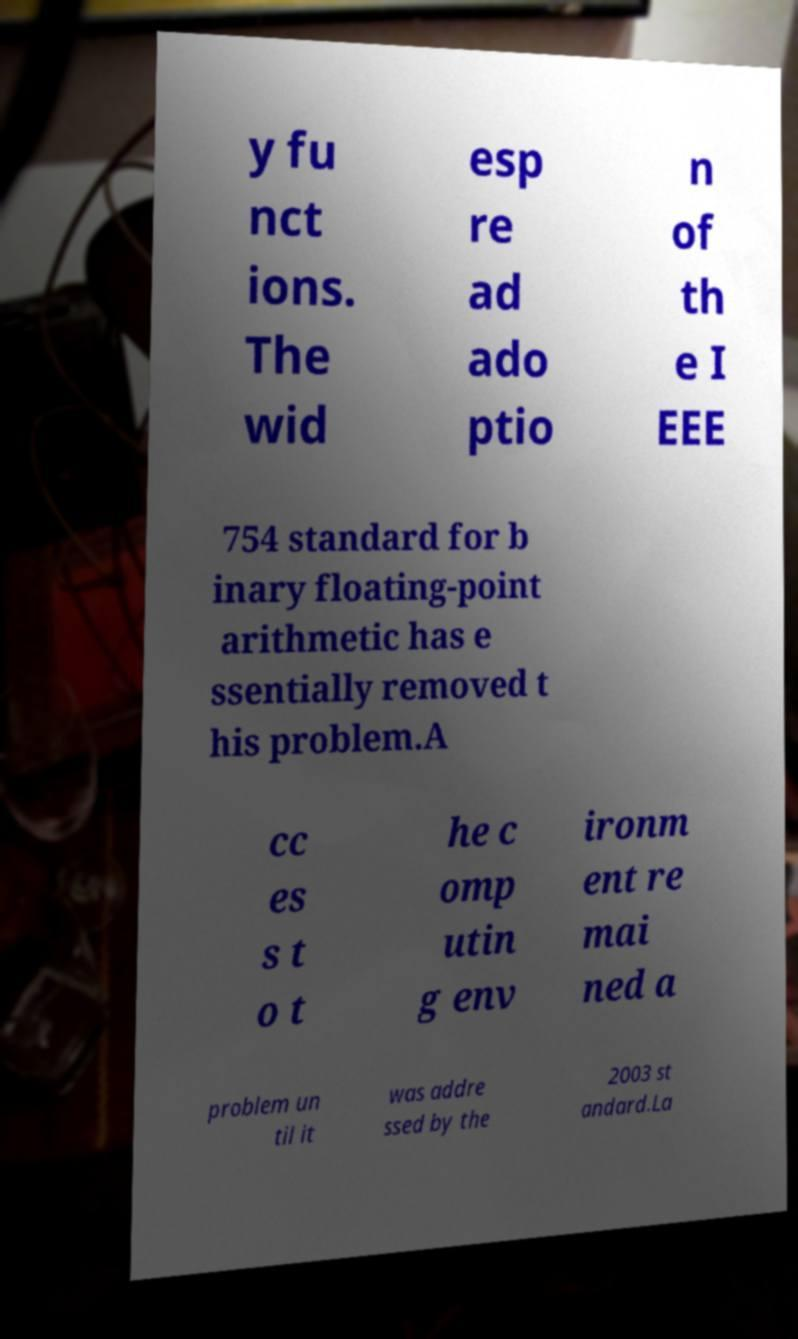Can you read and provide the text displayed in the image?This photo seems to have some interesting text. Can you extract and type it out for me? y fu nct ions. The wid esp re ad ado ptio n of th e I EEE 754 standard for b inary floating-point arithmetic has e ssentially removed t his problem.A cc es s t o t he c omp utin g env ironm ent re mai ned a problem un til it was addre ssed by the 2003 st andard.La 